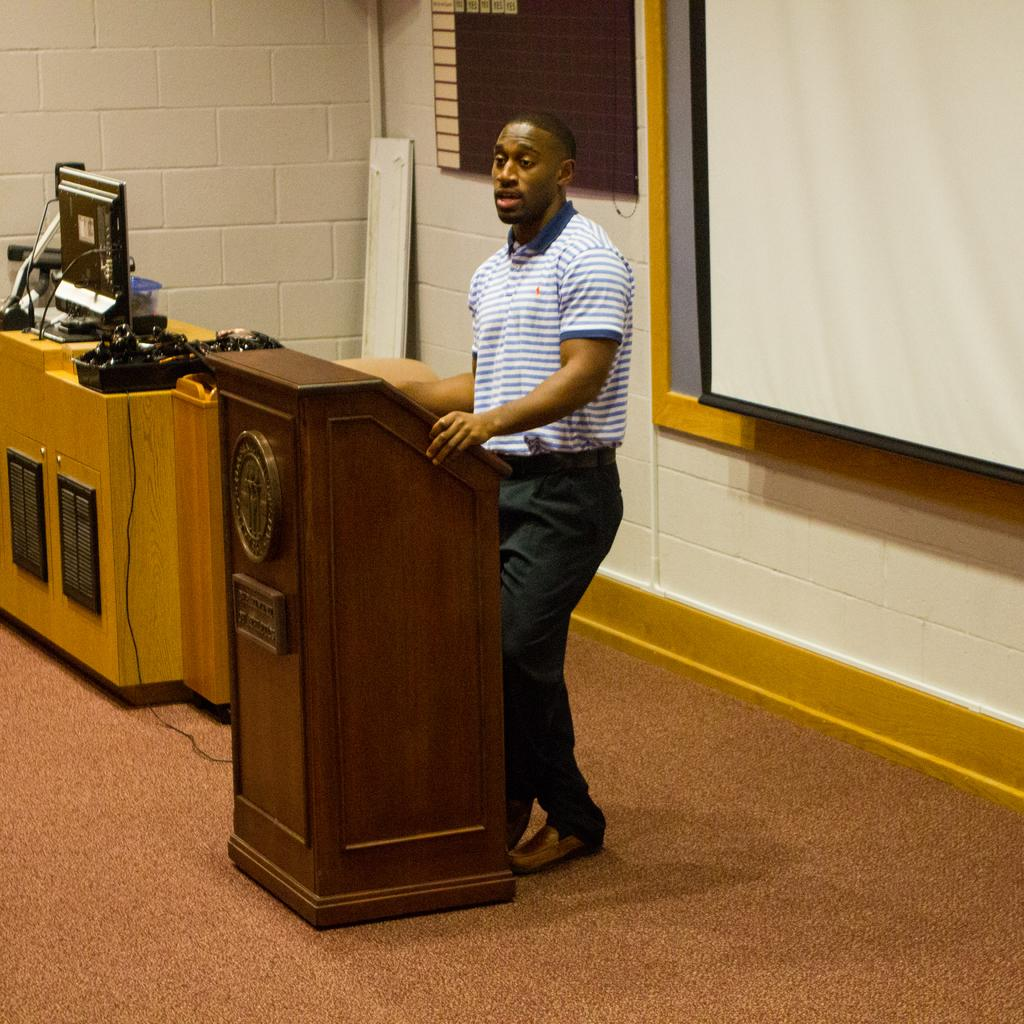What is the person in the image doing? The person is standing near a podium. What can be seen on the table in the image? There is a monitor on the table, as well as other objects. What is visible in the background of the image? There is a screen and a board in the background. What type of ball is being used to generate ideas in the image? There is no ball present in the image, and no indication that ideas are being generated. 